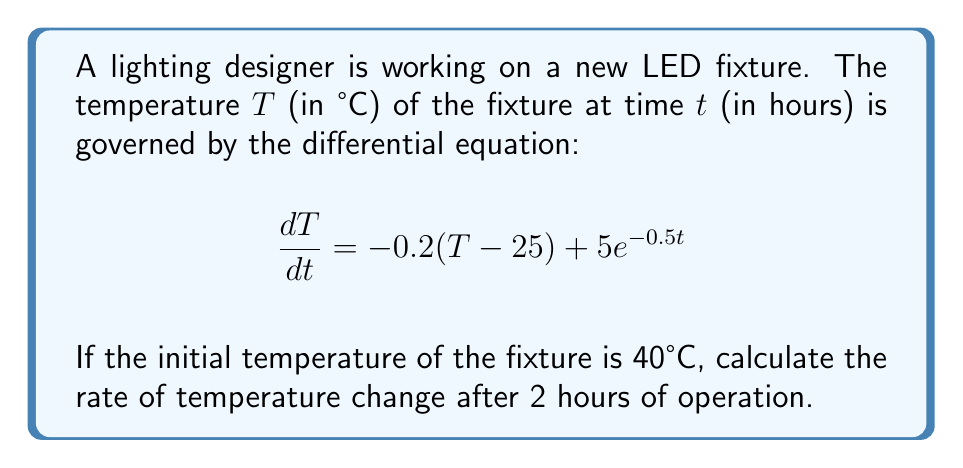Can you answer this question? To solve this problem, we need to follow these steps:

1) First, we need to find the temperature of the fixture after 2 hours. To do this, we need to solve the differential equation:

   $$\frac{dT}{dt} = -0.2(T - 25) + 5e^{-0.5t}$$

   This is a first-order linear differential equation.

2) The general solution to this equation is:

   $$T(t) = 25 + Ce^{-0.2t} + 10e^{-0.5t}$$

   where $C$ is a constant that depends on the initial conditions.

3) Given the initial condition $T(0) = 40$, we can find $C$:

   $$40 = 25 + C + 10$$
   $$C = 5$$

4) So, the particular solution is:

   $$T(t) = 25 + 5e^{-0.2t} + 10e^{-0.5t}$$

5) Now, to find the temperature at $t = 2$, we substitute $t = 2$ into this equation:

   $$T(2) = 25 + 5e^{-0.4} + 10e^{-1} \approx 33.37°C$$

6) To find the rate of temperature change at $t = 2$, we need to evaluate $\frac{dT}{dt}$ at $t = 2$. We can do this by substituting $t = 2$ and $T = 33.37$ into the original differential equation:

   $$\frac{dT}{dt} = -0.2(33.37 - 25) + 5e^{-0.5(2)}$$
   $$\frac{dT}{dt} = -1.674 + 5(0.3679)$$
   $$\frac{dT}{dt} = -1.674 + 1.8395 = 0.1655$$
Answer: The rate of temperature change after 2 hours of operation is approximately $0.1655°C/hour$. 